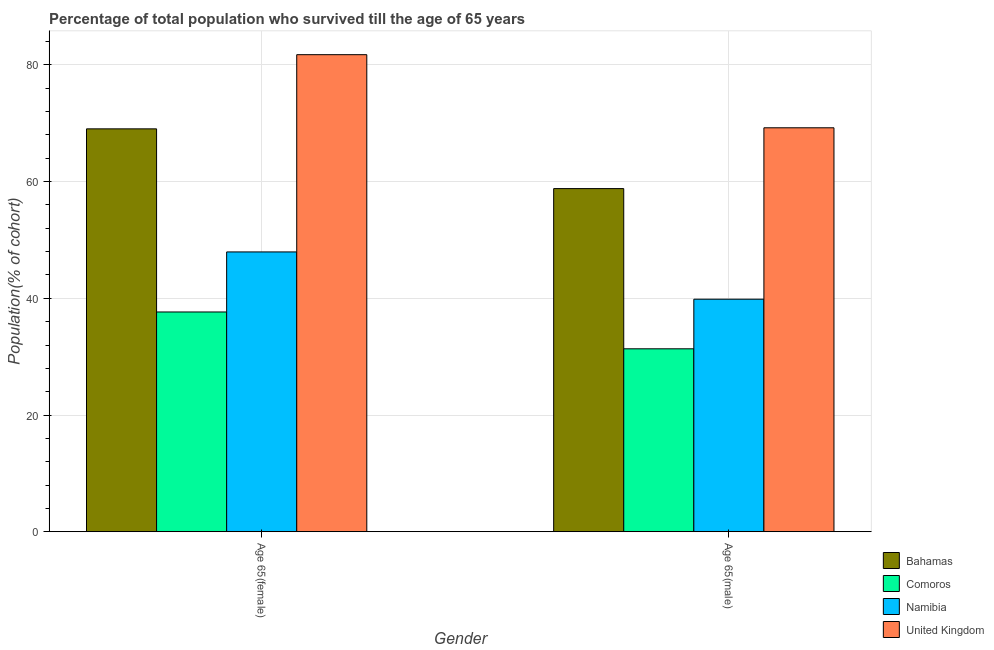How many different coloured bars are there?
Your answer should be compact. 4. How many groups of bars are there?
Your response must be concise. 2. How many bars are there on the 2nd tick from the left?
Offer a very short reply. 4. What is the label of the 1st group of bars from the left?
Offer a very short reply. Age 65(female). What is the percentage of female population who survived till age of 65 in Namibia?
Offer a terse response. 47.95. Across all countries, what is the maximum percentage of female population who survived till age of 65?
Provide a succinct answer. 81.76. Across all countries, what is the minimum percentage of female population who survived till age of 65?
Offer a very short reply. 37.66. In which country was the percentage of female population who survived till age of 65 minimum?
Offer a very short reply. Comoros. What is the total percentage of female population who survived till age of 65 in the graph?
Provide a short and direct response. 236.43. What is the difference between the percentage of female population who survived till age of 65 in United Kingdom and that in Comoros?
Provide a succinct answer. 44.1. What is the difference between the percentage of male population who survived till age of 65 in United Kingdom and the percentage of female population who survived till age of 65 in Comoros?
Your response must be concise. 31.57. What is the average percentage of male population who survived till age of 65 per country?
Your answer should be very brief. 49.81. What is the difference between the percentage of female population who survived till age of 65 and percentage of male population who survived till age of 65 in Bahamas?
Offer a terse response. 10.24. What is the ratio of the percentage of male population who survived till age of 65 in United Kingdom to that in Namibia?
Ensure brevity in your answer.  1.74. Is the percentage of male population who survived till age of 65 in United Kingdom less than that in Bahamas?
Make the answer very short. No. In how many countries, is the percentage of female population who survived till age of 65 greater than the average percentage of female population who survived till age of 65 taken over all countries?
Provide a short and direct response. 2. What does the 1st bar from the left in Age 65(female) represents?
Offer a terse response. Bahamas. What does the 4th bar from the right in Age 65(male) represents?
Give a very brief answer. Bahamas. How many bars are there?
Offer a very short reply. 8. Are all the bars in the graph horizontal?
Offer a very short reply. No. How many countries are there in the graph?
Provide a short and direct response. 4. What is the difference between two consecutive major ticks on the Y-axis?
Provide a short and direct response. 20. Are the values on the major ticks of Y-axis written in scientific E-notation?
Ensure brevity in your answer.  No. Does the graph contain any zero values?
Make the answer very short. No. Does the graph contain grids?
Your response must be concise. Yes. How are the legend labels stacked?
Make the answer very short. Vertical. What is the title of the graph?
Provide a short and direct response. Percentage of total population who survived till the age of 65 years. What is the label or title of the X-axis?
Provide a succinct answer. Gender. What is the label or title of the Y-axis?
Provide a short and direct response. Population(% of cohort). What is the Population(% of cohort) in Bahamas in Age 65(female)?
Make the answer very short. 69.05. What is the Population(% of cohort) in Comoros in Age 65(female)?
Provide a succinct answer. 37.66. What is the Population(% of cohort) of Namibia in Age 65(female)?
Offer a terse response. 47.95. What is the Population(% of cohort) in United Kingdom in Age 65(female)?
Keep it short and to the point. 81.76. What is the Population(% of cohort) in Bahamas in Age 65(male)?
Your answer should be compact. 58.81. What is the Population(% of cohort) of Comoros in Age 65(male)?
Provide a short and direct response. 31.35. What is the Population(% of cohort) in Namibia in Age 65(male)?
Offer a very short reply. 39.85. What is the Population(% of cohort) in United Kingdom in Age 65(male)?
Make the answer very short. 69.23. Across all Gender, what is the maximum Population(% of cohort) in Bahamas?
Offer a terse response. 69.05. Across all Gender, what is the maximum Population(% of cohort) in Comoros?
Keep it short and to the point. 37.66. Across all Gender, what is the maximum Population(% of cohort) of Namibia?
Your response must be concise. 47.95. Across all Gender, what is the maximum Population(% of cohort) of United Kingdom?
Offer a terse response. 81.76. Across all Gender, what is the minimum Population(% of cohort) of Bahamas?
Keep it short and to the point. 58.81. Across all Gender, what is the minimum Population(% of cohort) of Comoros?
Offer a very short reply. 31.35. Across all Gender, what is the minimum Population(% of cohort) of Namibia?
Offer a very short reply. 39.85. Across all Gender, what is the minimum Population(% of cohort) of United Kingdom?
Provide a succinct answer. 69.23. What is the total Population(% of cohort) of Bahamas in the graph?
Offer a very short reply. 127.86. What is the total Population(% of cohort) of Comoros in the graph?
Ensure brevity in your answer.  69.01. What is the total Population(% of cohort) in Namibia in the graph?
Your answer should be very brief. 87.81. What is the total Population(% of cohort) of United Kingdom in the graph?
Provide a short and direct response. 151. What is the difference between the Population(% of cohort) of Bahamas in Age 65(female) and that in Age 65(male)?
Offer a terse response. 10.24. What is the difference between the Population(% of cohort) of Comoros in Age 65(female) and that in Age 65(male)?
Provide a succinct answer. 6.31. What is the difference between the Population(% of cohort) of Namibia in Age 65(female) and that in Age 65(male)?
Your answer should be compact. 8.1. What is the difference between the Population(% of cohort) in United Kingdom in Age 65(female) and that in Age 65(male)?
Offer a very short reply. 12.53. What is the difference between the Population(% of cohort) of Bahamas in Age 65(female) and the Population(% of cohort) of Comoros in Age 65(male)?
Your answer should be compact. 37.7. What is the difference between the Population(% of cohort) of Bahamas in Age 65(female) and the Population(% of cohort) of Namibia in Age 65(male)?
Offer a terse response. 29.2. What is the difference between the Population(% of cohort) in Bahamas in Age 65(female) and the Population(% of cohort) in United Kingdom in Age 65(male)?
Your answer should be very brief. -0.18. What is the difference between the Population(% of cohort) in Comoros in Age 65(female) and the Population(% of cohort) in Namibia in Age 65(male)?
Your answer should be very brief. -2.19. What is the difference between the Population(% of cohort) of Comoros in Age 65(female) and the Population(% of cohort) of United Kingdom in Age 65(male)?
Offer a terse response. -31.57. What is the difference between the Population(% of cohort) of Namibia in Age 65(female) and the Population(% of cohort) of United Kingdom in Age 65(male)?
Give a very brief answer. -21.28. What is the average Population(% of cohort) in Bahamas per Gender?
Give a very brief answer. 63.93. What is the average Population(% of cohort) in Comoros per Gender?
Offer a terse response. 34.51. What is the average Population(% of cohort) in Namibia per Gender?
Give a very brief answer. 43.9. What is the average Population(% of cohort) in United Kingdom per Gender?
Your answer should be compact. 75.5. What is the difference between the Population(% of cohort) in Bahamas and Population(% of cohort) in Comoros in Age 65(female)?
Give a very brief answer. 31.39. What is the difference between the Population(% of cohort) in Bahamas and Population(% of cohort) in Namibia in Age 65(female)?
Make the answer very short. 21.1. What is the difference between the Population(% of cohort) of Bahamas and Population(% of cohort) of United Kingdom in Age 65(female)?
Offer a very short reply. -12.71. What is the difference between the Population(% of cohort) in Comoros and Population(% of cohort) in Namibia in Age 65(female)?
Keep it short and to the point. -10.29. What is the difference between the Population(% of cohort) in Comoros and Population(% of cohort) in United Kingdom in Age 65(female)?
Provide a short and direct response. -44.1. What is the difference between the Population(% of cohort) in Namibia and Population(% of cohort) in United Kingdom in Age 65(female)?
Give a very brief answer. -33.81. What is the difference between the Population(% of cohort) in Bahamas and Population(% of cohort) in Comoros in Age 65(male)?
Make the answer very short. 27.46. What is the difference between the Population(% of cohort) in Bahamas and Population(% of cohort) in Namibia in Age 65(male)?
Provide a short and direct response. 18.96. What is the difference between the Population(% of cohort) in Bahamas and Population(% of cohort) in United Kingdom in Age 65(male)?
Your answer should be very brief. -10.42. What is the difference between the Population(% of cohort) of Comoros and Population(% of cohort) of Namibia in Age 65(male)?
Ensure brevity in your answer.  -8.5. What is the difference between the Population(% of cohort) of Comoros and Population(% of cohort) of United Kingdom in Age 65(male)?
Make the answer very short. -37.88. What is the difference between the Population(% of cohort) in Namibia and Population(% of cohort) in United Kingdom in Age 65(male)?
Provide a short and direct response. -29.38. What is the ratio of the Population(% of cohort) in Bahamas in Age 65(female) to that in Age 65(male)?
Offer a terse response. 1.17. What is the ratio of the Population(% of cohort) of Comoros in Age 65(female) to that in Age 65(male)?
Keep it short and to the point. 1.2. What is the ratio of the Population(% of cohort) of Namibia in Age 65(female) to that in Age 65(male)?
Provide a short and direct response. 1.2. What is the ratio of the Population(% of cohort) in United Kingdom in Age 65(female) to that in Age 65(male)?
Your answer should be very brief. 1.18. What is the difference between the highest and the second highest Population(% of cohort) of Bahamas?
Make the answer very short. 10.24. What is the difference between the highest and the second highest Population(% of cohort) of Comoros?
Your response must be concise. 6.31. What is the difference between the highest and the second highest Population(% of cohort) of Namibia?
Your answer should be compact. 8.1. What is the difference between the highest and the second highest Population(% of cohort) of United Kingdom?
Give a very brief answer. 12.53. What is the difference between the highest and the lowest Population(% of cohort) in Bahamas?
Keep it short and to the point. 10.24. What is the difference between the highest and the lowest Population(% of cohort) of Comoros?
Offer a terse response. 6.31. What is the difference between the highest and the lowest Population(% of cohort) of Namibia?
Your answer should be compact. 8.1. What is the difference between the highest and the lowest Population(% of cohort) of United Kingdom?
Offer a terse response. 12.53. 